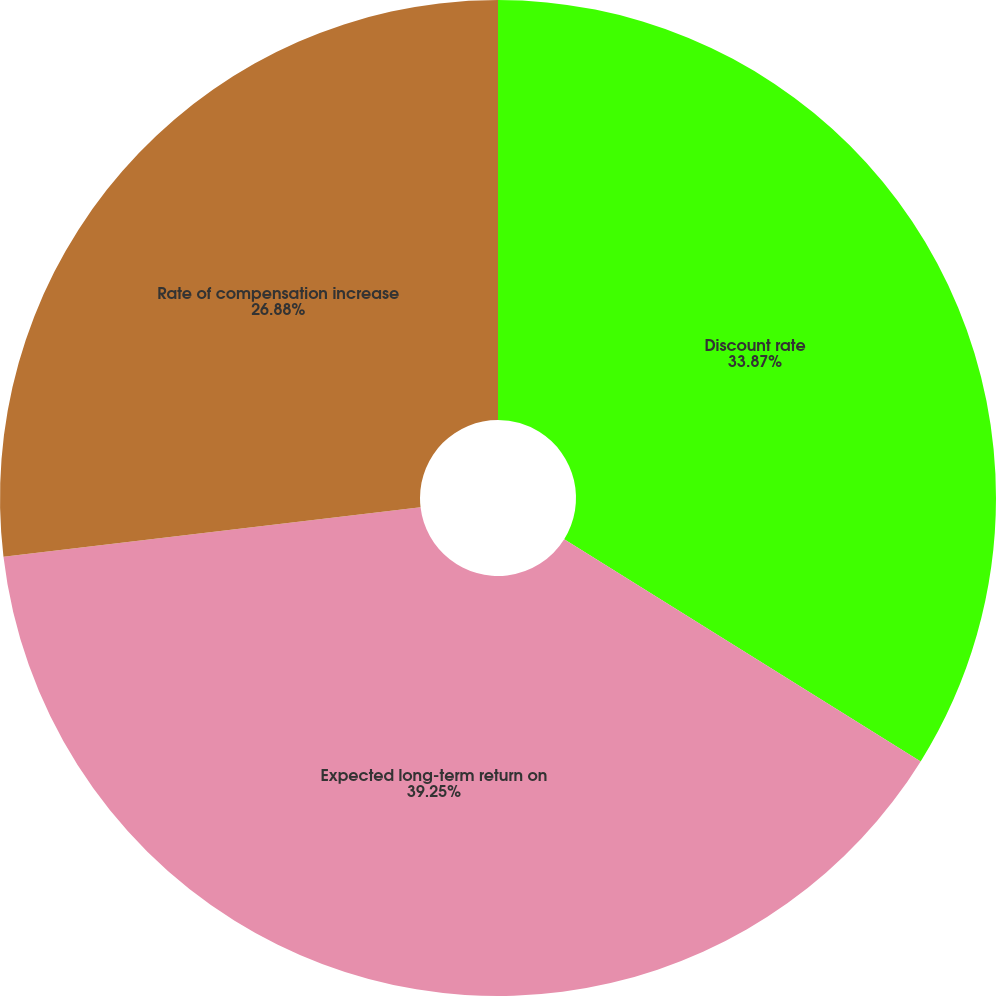<chart> <loc_0><loc_0><loc_500><loc_500><pie_chart><fcel>Discount rate<fcel>Expected long-term return on<fcel>Rate of compensation increase<nl><fcel>33.87%<fcel>39.25%<fcel>26.88%<nl></chart> 